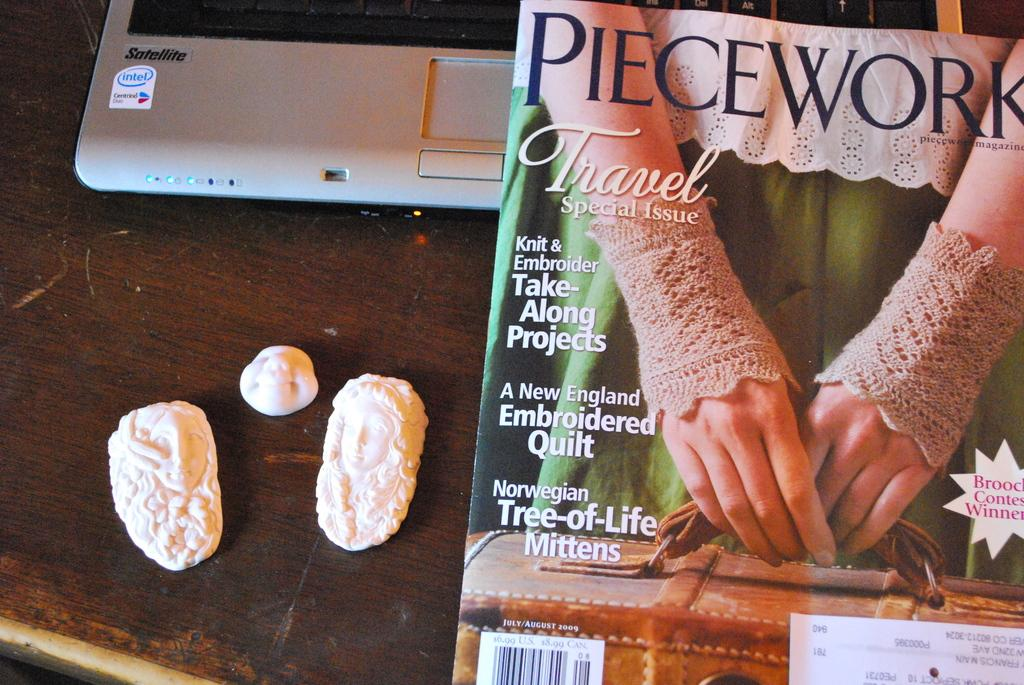What piece of furniture is present in the image? There is a table in the image. What electronic device is on the table? There is a laptop on the table. What type of reading material is on the table? There is a magazine on the table. What other objects can be seen on the table? There are other objects on the table. What direction does the laptop face in the image? The direction the laptop faces cannot be determined from the image, as it is a still image and does not show movement or orientation. 